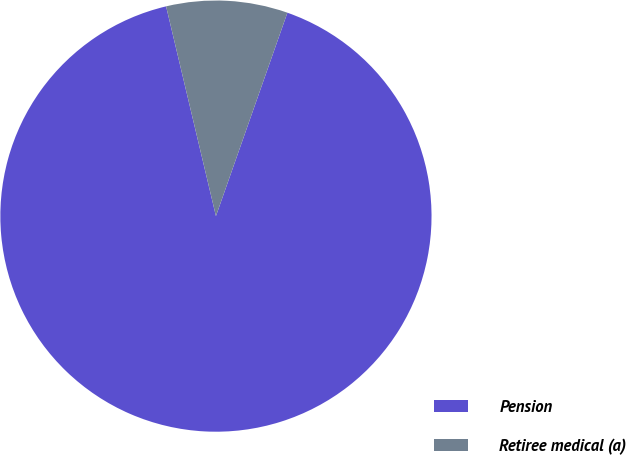Convert chart to OTSL. <chart><loc_0><loc_0><loc_500><loc_500><pie_chart><fcel>Pension<fcel>Retiree medical (a)<nl><fcel>90.91%<fcel>9.09%<nl></chart> 